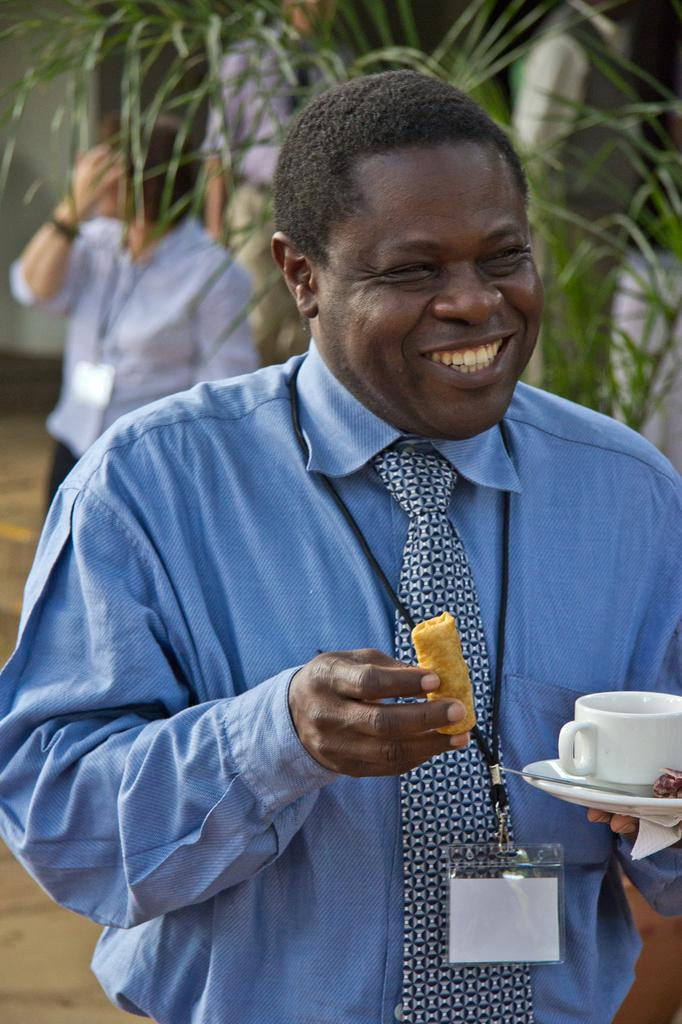What is the man in the image doing? The man is standing and holding a cup, a plate, and a biscuit. What is the man's facial expression in the image? The man has a smile on his face. What can be seen in the background of the image? There is a tree and other people in the background of the image. What type of magic is the man performing in the image? There is no indication of magic or any magical activity in the image. 